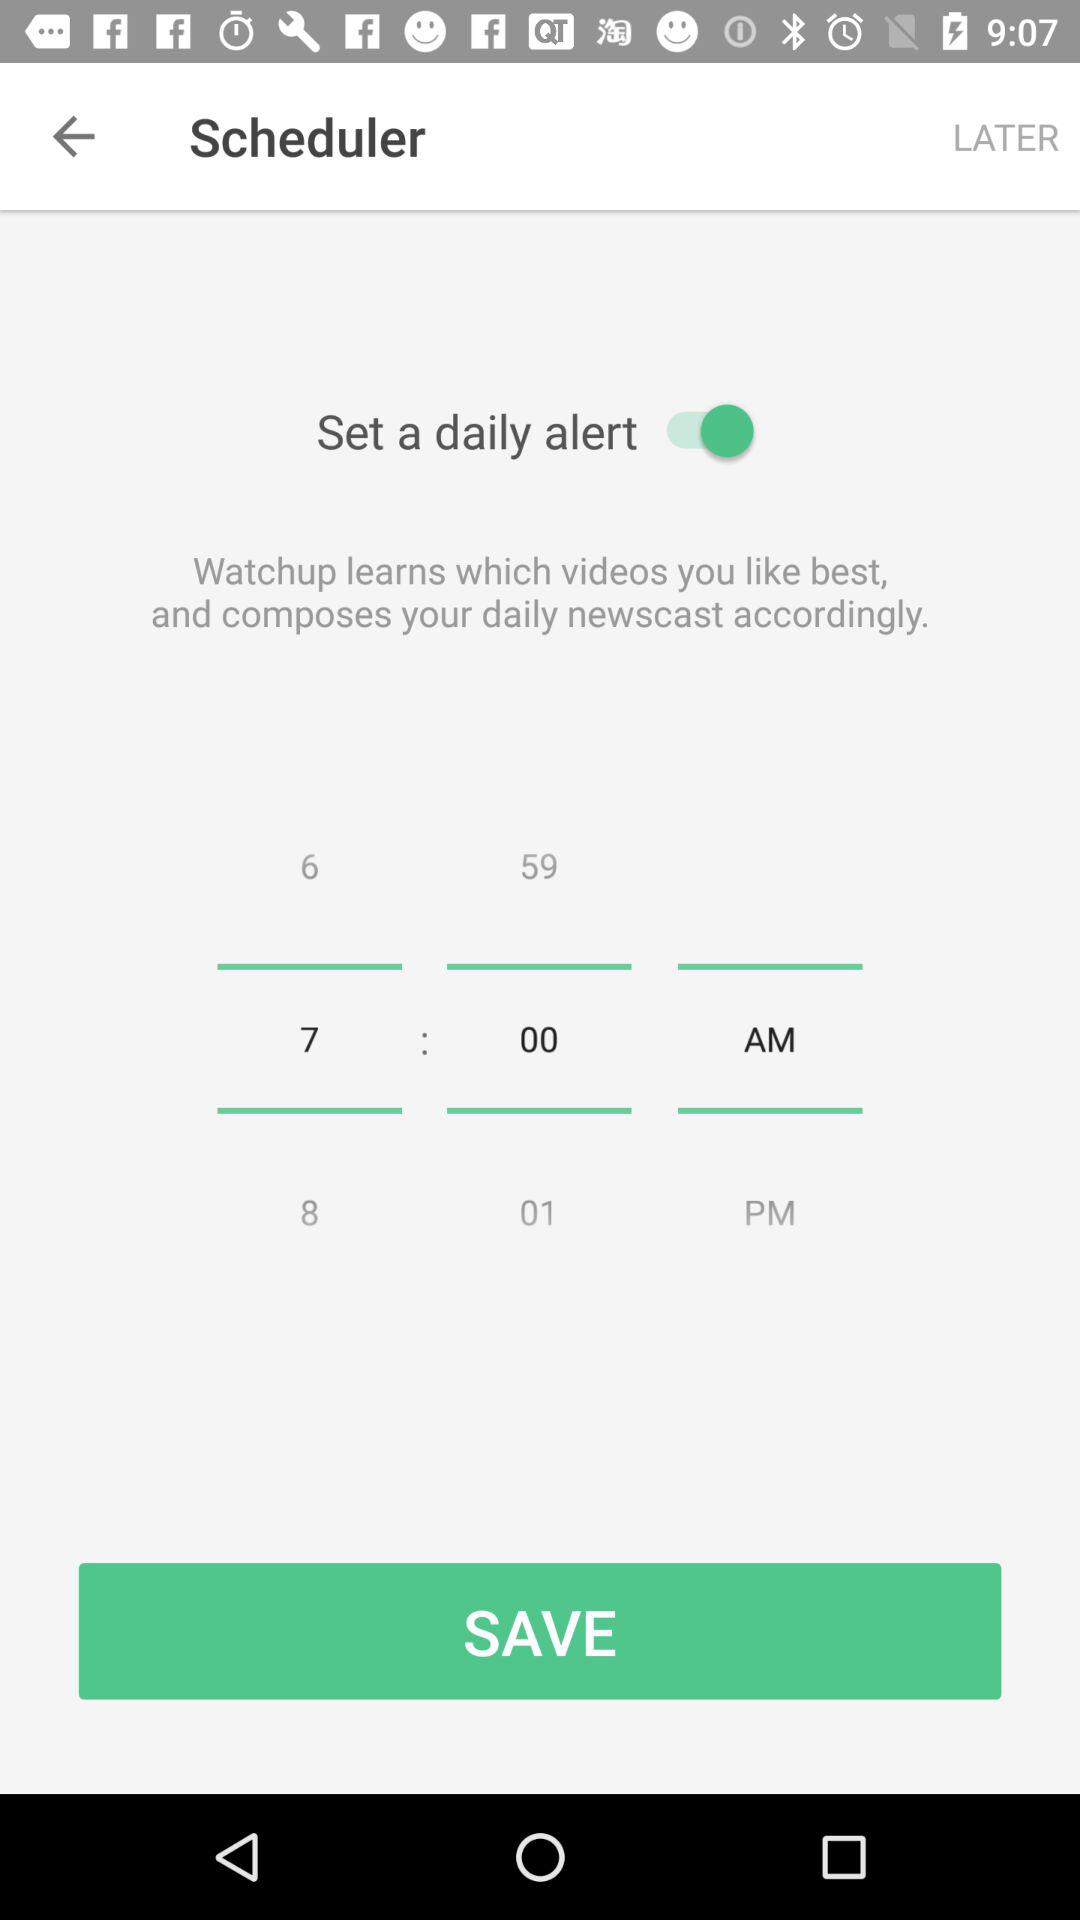What is the status of "Set a daily alert"? The status is "on". 